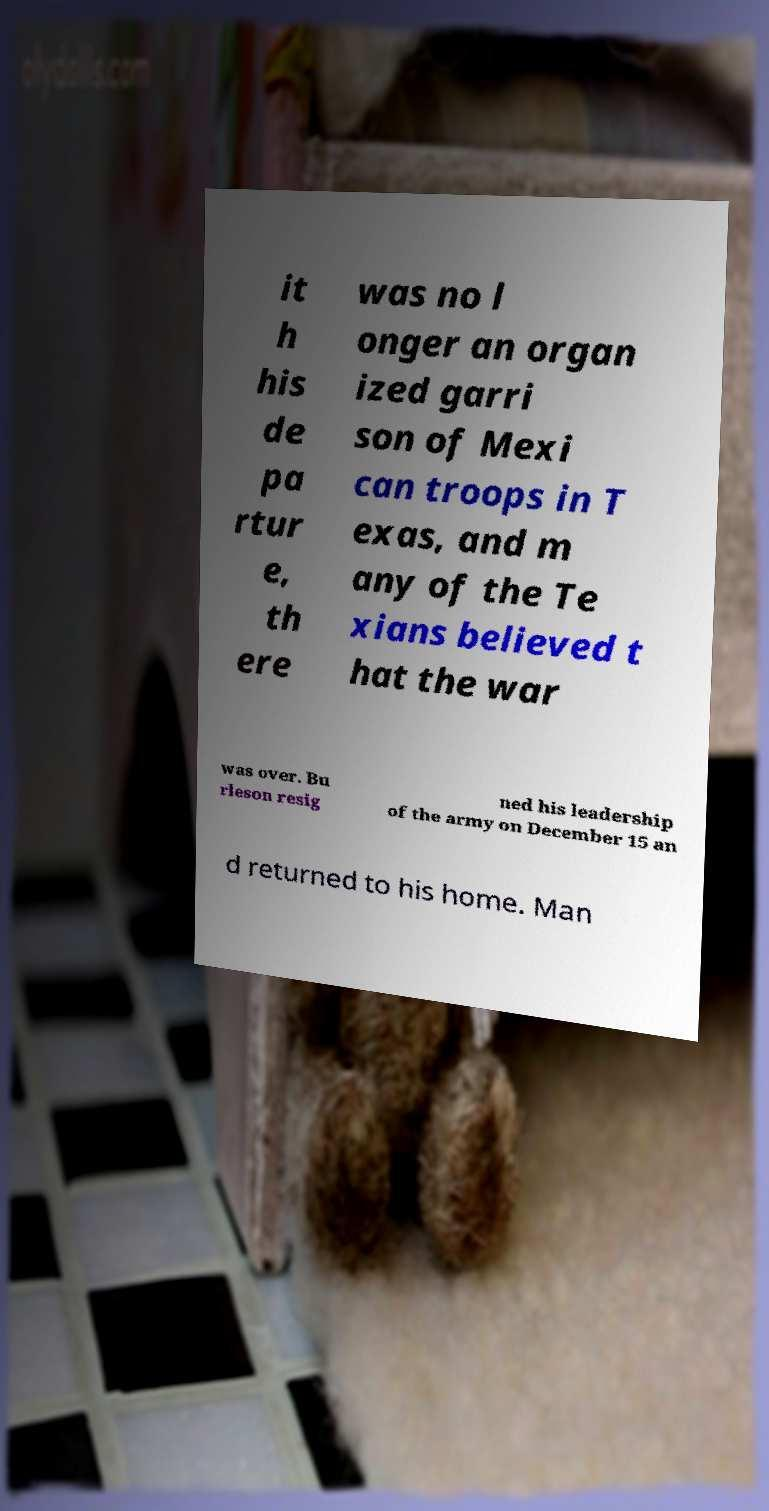There's text embedded in this image that I need extracted. Can you transcribe it verbatim? it h his de pa rtur e, th ere was no l onger an organ ized garri son of Mexi can troops in T exas, and m any of the Te xians believed t hat the war was over. Bu rleson resig ned his leadership of the army on December 15 an d returned to his home. Man 